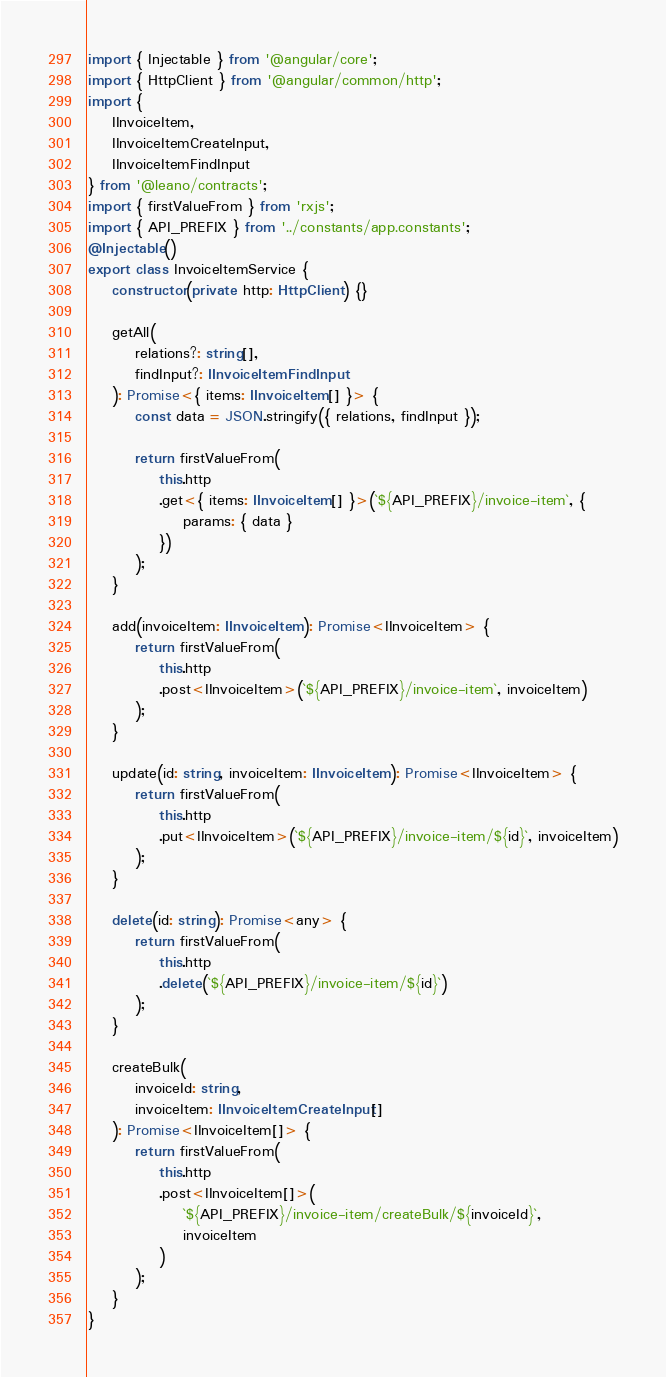Convert code to text. <code><loc_0><loc_0><loc_500><loc_500><_TypeScript_>import { Injectable } from '@angular/core';
import { HttpClient } from '@angular/common/http';
import {
	IInvoiceItem,
	IInvoiceItemCreateInput,
	IInvoiceItemFindInput
} from '@leano/contracts';
import { firstValueFrom } from 'rxjs';
import { API_PREFIX } from '../constants/app.constants';
@Injectable()
export class InvoiceItemService {
	constructor(private http: HttpClient) {}

	getAll(
		relations?: string[],
		findInput?: IInvoiceItemFindInput
	): Promise<{ items: IInvoiceItem[] }> {
		const data = JSON.stringify({ relations, findInput });

		return firstValueFrom(
			this.http
			.get<{ items: IInvoiceItem[] }>(`${API_PREFIX}/invoice-item`, {
				params: { data }
			})
		);
	}

	add(invoiceItem: IInvoiceItem): Promise<IInvoiceItem> {
		return firstValueFrom(
			this.http
			.post<IInvoiceItem>(`${API_PREFIX}/invoice-item`, invoiceItem)
		);
	}

	update(id: string, invoiceItem: IInvoiceItem): Promise<IInvoiceItem> {
		return firstValueFrom(
			this.http
			.put<IInvoiceItem>(`${API_PREFIX}/invoice-item/${id}`, invoiceItem)
		);
	}

	delete(id: string): Promise<any> {
		return firstValueFrom(
			this.http
			.delete(`${API_PREFIX}/invoice-item/${id}`)
		);
	}

	createBulk(
		invoiceId: string,
		invoiceItem: IInvoiceItemCreateInput[]
	): Promise<IInvoiceItem[]> {
		return firstValueFrom(
			this.http
			.post<IInvoiceItem[]>(
				`${API_PREFIX}/invoice-item/createBulk/${invoiceId}`,
				invoiceItem
			)
		);
	}
}
</code> 